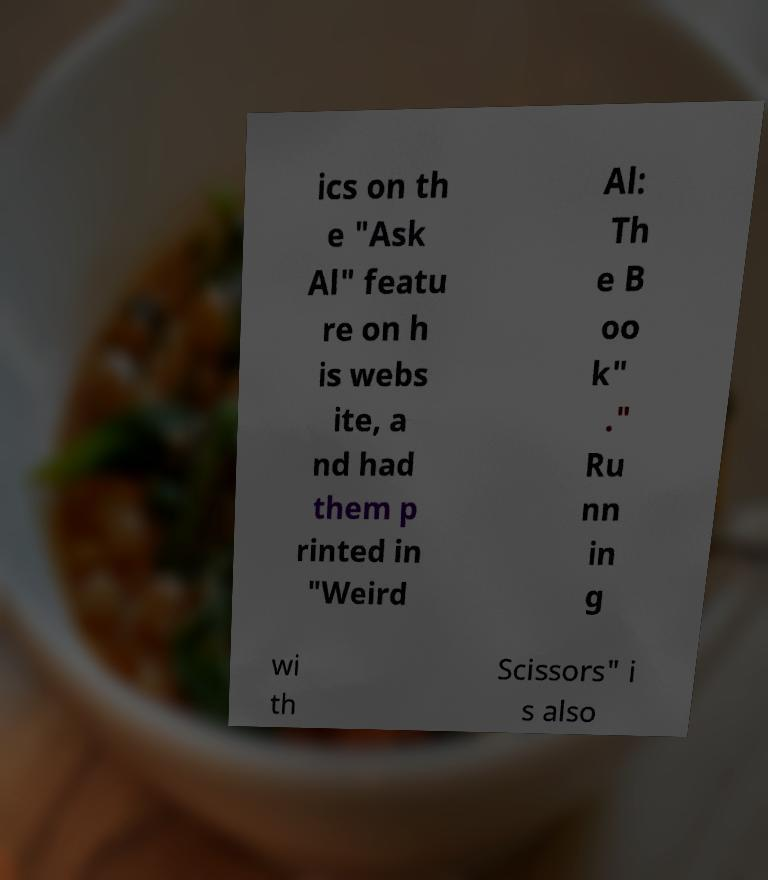For documentation purposes, I need the text within this image transcribed. Could you provide that? ics on th e "Ask Al" featu re on h is webs ite, a nd had them p rinted in "Weird Al: Th e B oo k" ." Ru nn in g wi th Scissors" i s also 